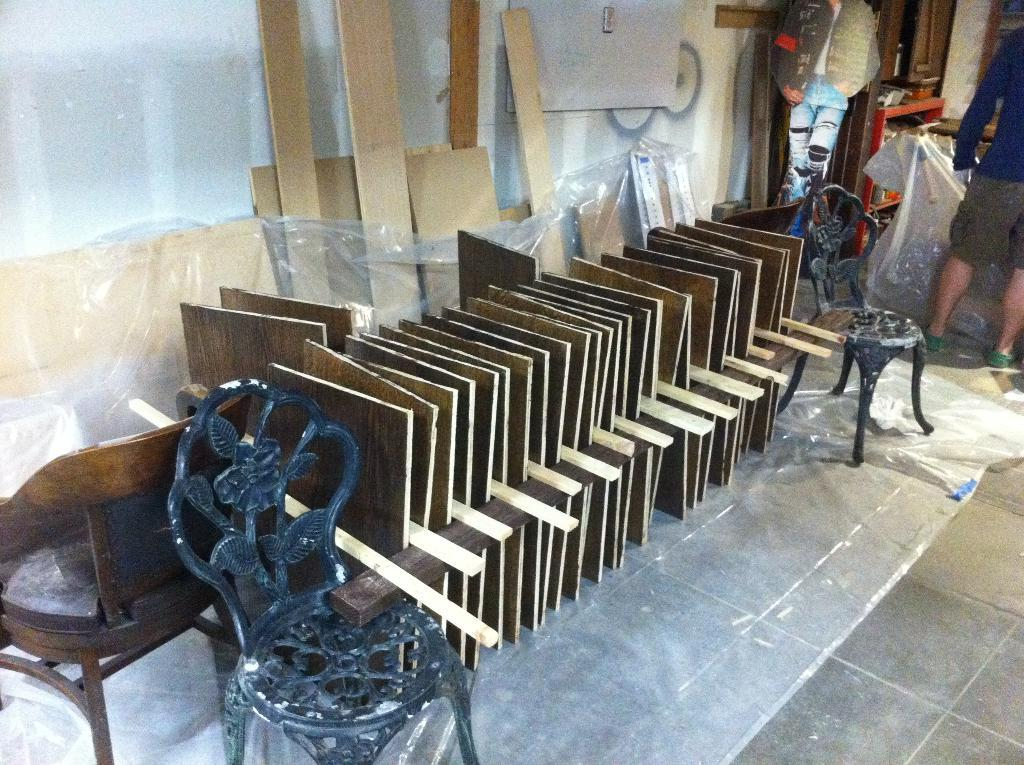What type of objects are arranged on the floor in the image? There are wooden cardboard pieces arranged in a sequence manner on the floor. What material are the objects made of? The objects are made of wood. Can you describe the man standing on the floor in the image? There is a man standing on the floor in the image. What type of scale is the man using to weigh the wooden pieces in the image? There is no scale present in the image, and the man is not shown weighing any wooden pieces. 